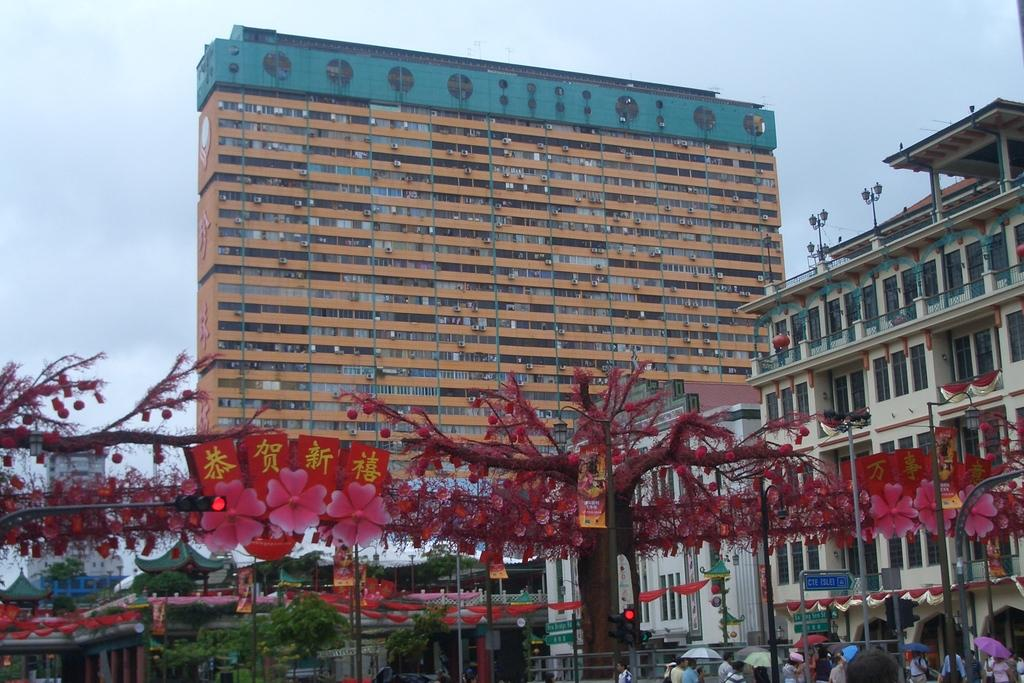How many people are in the image? There is a group of persons in the image, but the exact number cannot be determined from the provided facts. What type of vegetation is at the bottom of the image? There are trees at the bottom of the image. What type of structures can be seen in the background of the image? There are buildings in the background of the image. What is visible at the top of the image? The sky is visible at the top of the image. How much sugar is present in the seed depicted in the image? There is no seed or sugar present in the image. What type of week is being celebrated in the image? There is no reference to a week or any celebrations in the image. 